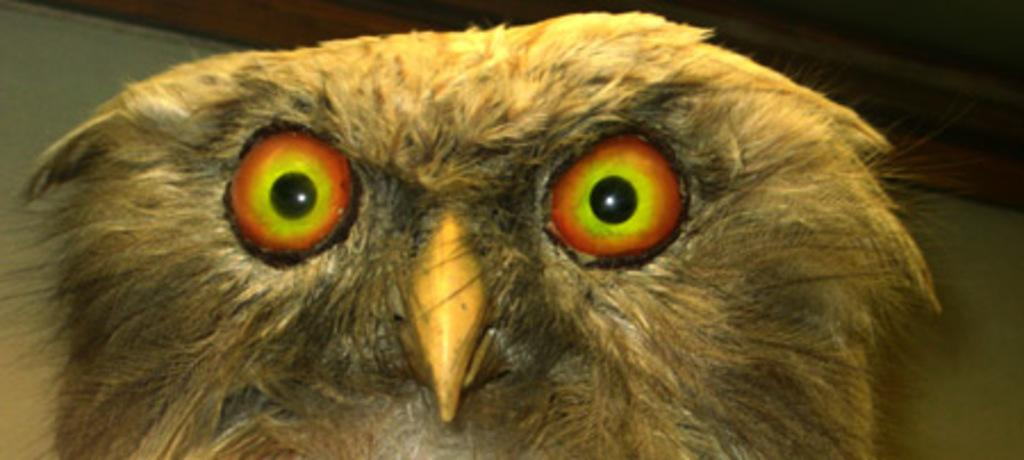What type of animal is in the image? There is an owl in the image. What can be seen in the background of the image? There is a wall in the background of the image. What flavor of dime can be seen in the image? There is no dime present in the image, and therefore no flavor can be associated with it. 